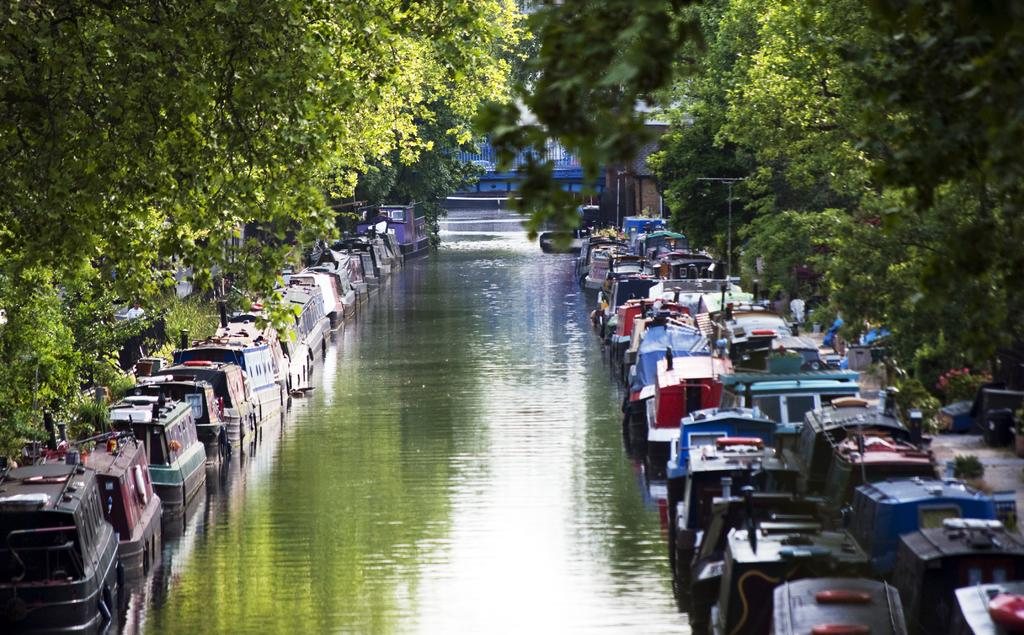What type of boats are in the image? There are canal boats in the image. Where are the canal boats located? The canal boats are on the water. What can be seen on either side of the water in the image? There are trees on either side of the water. What type of harmony can be heard coming from the canal boats in the image? There is no indication of any sound, such as harmony, coming from the canal boats in the image. 